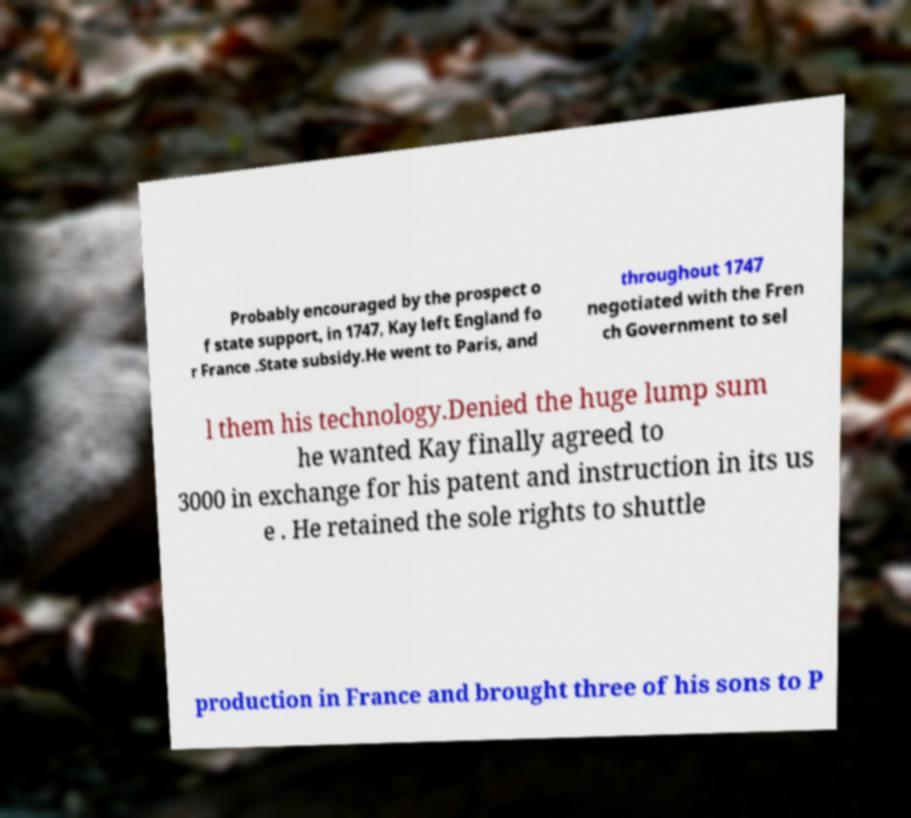What messages or text are displayed in this image? I need them in a readable, typed format. Probably encouraged by the prospect o f state support, in 1747, Kay left England fo r France .State subsidy.He went to Paris, and throughout 1747 negotiated with the Fren ch Government to sel l them his technology.Denied the huge lump sum he wanted Kay finally agreed to 3000 in exchange for his patent and instruction in its us e . He retained the sole rights to shuttle production in France and brought three of his sons to P 